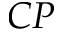<formula> <loc_0><loc_0><loc_500><loc_500>C P</formula> 